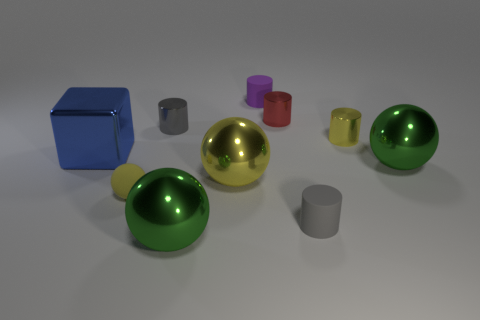What is the size of the yellow shiny thing in front of the big cube?
Offer a very short reply. Large. Do the yellow sphere behind the yellow matte sphere and the yellow cylinder have the same size?
Your answer should be compact. No. What size is the blue metal object?
Make the answer very short. Large. The other yellow thing that is the same shape as the yellow rubber thing is what size?
Make the answer very short. Large. Does the matte object that is right of the red object have the same color as the tiny metallic thing that is left of the small purple rubber object?
Your answer should be very brief. Yes. The yellow metallic object in front of the large green sphere to the right of the small yellow metal object is what shape?
Your answer should be compact. Sphere. What is the shape of the green shiny thing on the right side of the gray thing that is in front of the green metallic object to the right of the gray rubber cylinder?
Your answer should be compact. Sphere. How many objects are either tiny objects that are behind the tiny yellow cylinder or big green metallic spheres that are in front of the rubber ball?
Offer a very short reply. 4. Does the matte ball have the same size as the green metallic ball in front of the yellow rubber object?
Provide a short and direct response. No. Are the gray cylinder that is in front of the large yellow thing and the cylinder that is behind the red metal object made of the same material?
Provide a succinct answer. Yes. 